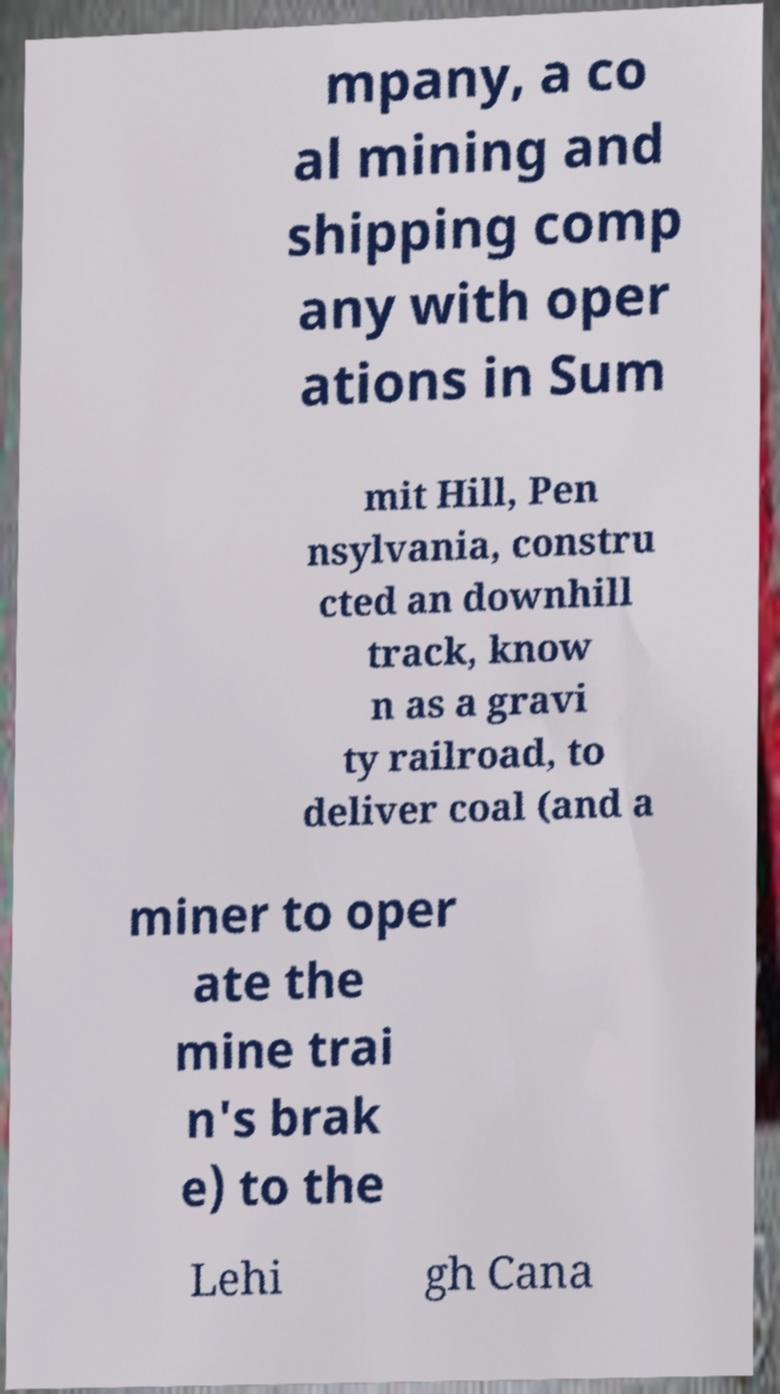Can you accurately transcribe the text from the provided image for me? mpany, a co al mining and shipping comp any with oper ations in Sum mit Hill, Pen nsylvania, constru cted an downhill track, know n as a gravi ty railroad, to deliver coal (and a miner to oper ate the mine trai n's brak e) to the Lehi gh Cana 